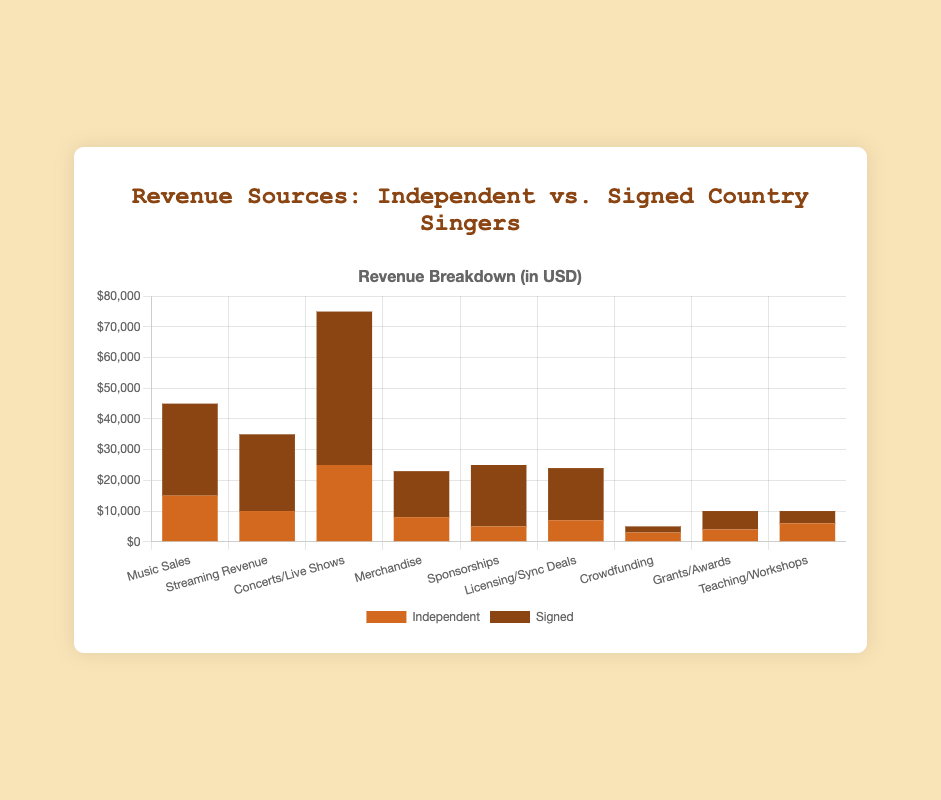Which revenue source generates the most income overall for signed country singers? Look for the highest bar in the "Signed" category. The "Concerts/Live Shows" bar is the tallest for signed country singers.
Answer: Concerts/Live Shows How much more revenue do signed singers earn from Sponsorships compared to independent singers? Identify the "Sponsorships" category for both independent ($5,000) and signed singers ($20,000). Calculate the difference: $20,000 - $5,000 = $15,000.
Answer: $15,000 What is the total revenue from Music Sales, Streaming Revenue, and Concerts/Live Shows for independent singers? Sum the revenue values for the specified categories: $15,000 (Music Sales) + $10,000 (Streaming Revenue) + $25,000 (Concerts/Live Shows) = $50,000.
Answer: $50,000 Which revenue source has the smallest difference in income between independent and signed singers? Compute the differences for each category: 
- Music Sales: $30,000 - $15,000 = $15,000
- Streaming Revenue: $25,000 - $10,000 = $15,000
- Concerts/Live Shows: $50,000 - $25,000 = $25,000
- Merchandise: $15,000 - $8,000 = $7,000
- Sponsorships: $20,000 - $5,000 = $15,000
- Licensing/Sync Deals: $17,000 - $7,000 = $10,000
- Crowdfunding: $3,000 - $2,000 = $1,000
- Grants/Awards: $6,000 - $4,000 = $2,000
- Teaching/Workshops: $6,000 - $4,000 = $2,000
Crowdfunding has the smallest difference.
Answer: Crowdfunding What is the percentage of total revenue from Merchandise for independent singers? Calculate the total revenue for independent singers, then find the percentage: Total revenue = $15,000 + $10,000 + $25,000 + $8,000 + $5,000 + $7,000 + $3,000 + $4,000 + $6,000 = $83,000. Percentage from Merchandise = ($8,000 / $83,000) * 100 ≈ 9.64%.
Answer: ≈ 9.64% Which revenue source contributes equally to both independent and signed singers? Compare values in both categories and find the one with same values: Both "Teaching/Workshops" and "Crowdfunding" have the same revenue marked for both independent ($6,000 and $3,000) and signed singers ($4,000 and $2,000). Therefore, none contribute equally.
Answer: None If the combined revenue of independent and signed singers from Licensing/Sync Deals were evenly split, how much would each group get? Add the revenues from both types and divide by 2: Combined revenue = $7,000 (Independent) + $17,000 (Signed) = $24,000. Each group would get $24,000 / 2 = $12,000.
Answer: $12,000 Considering all revenue sources, which category shows the biggest proportional difference between independent and signed singers? Calculate the proportional differences for each category:
- Music Sales: (30,000 - 15,000)/15,000 = 1 or 100%
- Streaming Revenue: (25,000 - 10,000)/10,000 = 1.5 or 150%
- Concerts/Live Shows: (50,000 - 25,000)/25,000 = 1 or 100%
- Merchandise: (15,000 - 8,000)/8,000 = 0.875 or 87.5%
- Sponsorships: (20,000 - 5,000)/5,000 = 3 or 300%
- Licensing/Sync Deals: (17,000 - 7,000)/7,000 = 1.429 or 142.9%
- Crowdfunding: (3,000 - 2,000)/2,000 = 0.5 or 50%
- Grants/Awards: (6,000 - 4,000)/4,000 = 0.5 or 50%
- Teaching/Workshops: (6,000 - 4,000)/4,000 = 0.5 or 50%
The category with the largest proportion is Sponsorships.
Answer: Sponsorships 